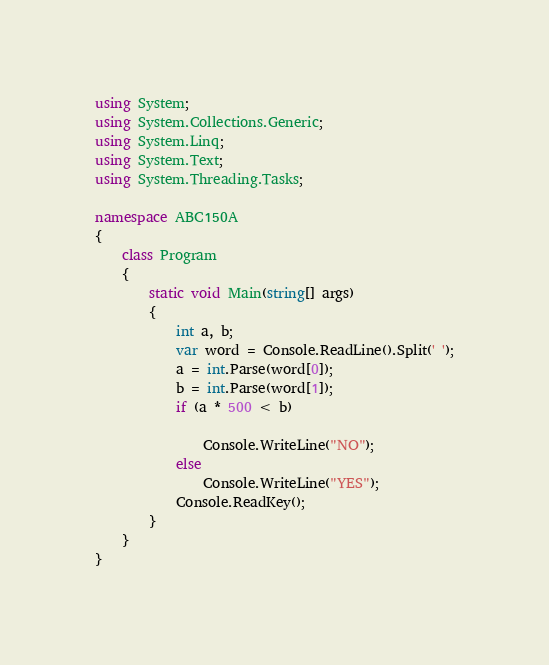Convert code to text. <code><loc_0><loc_0><loc_500><loc_500><_C#_>using System;
using System.Collections.Generic;
using System.Linq;
using System.Text;
using System.Threading.Tasks;

namespace ABC150A
{
	class Program
	{
		static void Main(string[] args)
		{
			int a, b;
			var word = Console.ReadLine().Split(' ');
			a = int.Parse(word[0]);
			b = int.Parse(word[1]);
			if (a * 500 < b)
			
				Console.WriteLine("NO");
			else
				Console.WriteLine("YES");
			Console.ReadKey();
		}
	}
}
</code> 